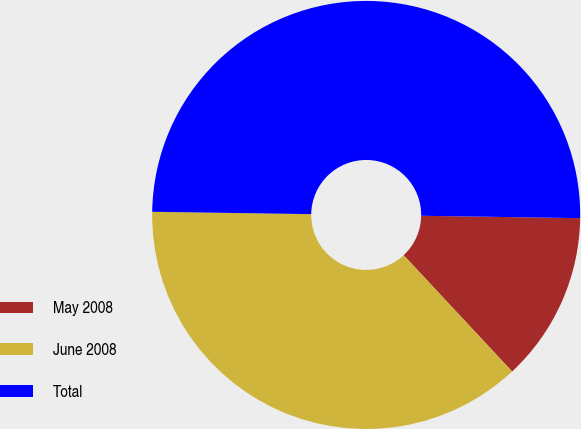Convert chart to OTSL. <chart><loc_0><loc_0><loc_500><loc_500><pie_chart><fcel>May 2008<fcel>June 2008<fcel>Total<nl><fcel>12.82%<fcel>37.18%<fcel>50.0%<nl></chart> 